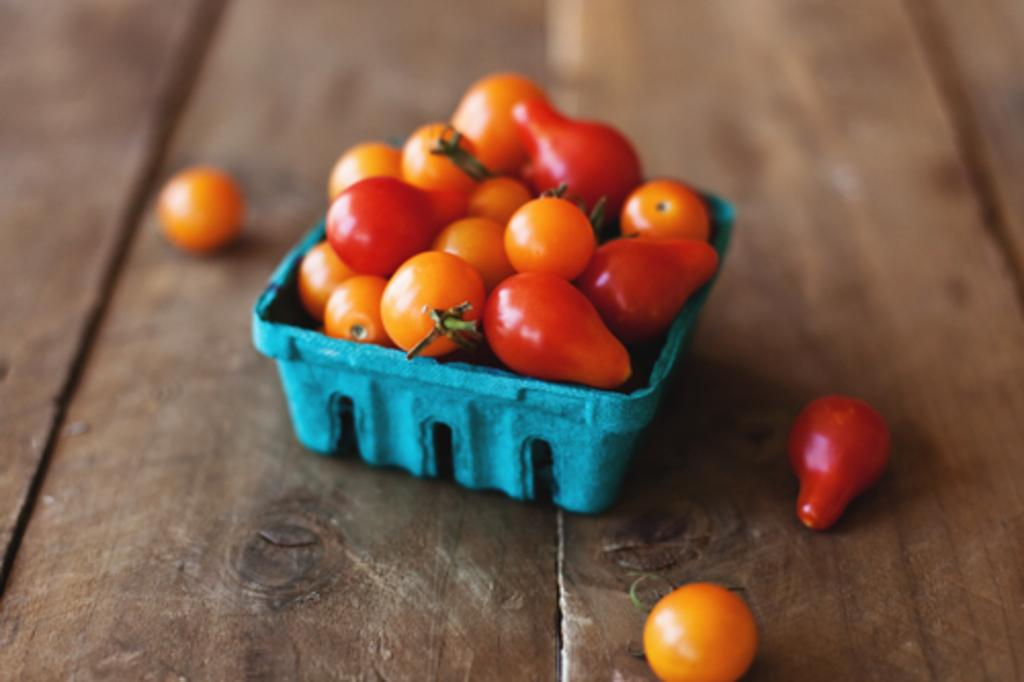What type of fruit is present in the image? There are tomatoes in the image. How are the tomatoes arranged or stored in the image? The tomatoes are in a container. What is the chance of finding a bedroom in the middle of the tomatoes in the image? There is no bedroom present in the image, and the tomatoes are in a container, so it is not possible to find a bedroom in the middle of the tomatoes. 